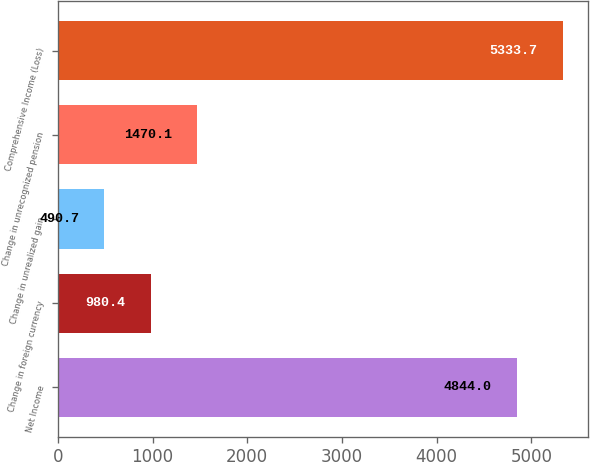Convert chart. <chart><loc_0><loc_0><loc_500><loc_500><bar_chart><fcel>Net Income<fcel>Change in foreign currency<fcel>Change in unrealized gain<fcel>Change in unrecognized pension<fcel>Comprehensive Income (Loss)<nl><fcel>4844<fcel>980.4<fcel>490.7<fcel>1470.1<fcel>5333.7<nl></chart> 